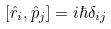Convert formula to latex. <formula><loc_0><loc_0><loc_500><loc_500>[ \hat { r } _ { i } , \hat { p } _ { j } ] = i \hbar { \delta } _ { i j }</formula> 